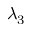Convert formula to latex. <formula><loc_0><loc_0><loc_500><loc_500>\lambda _ { 3 }</formula> 